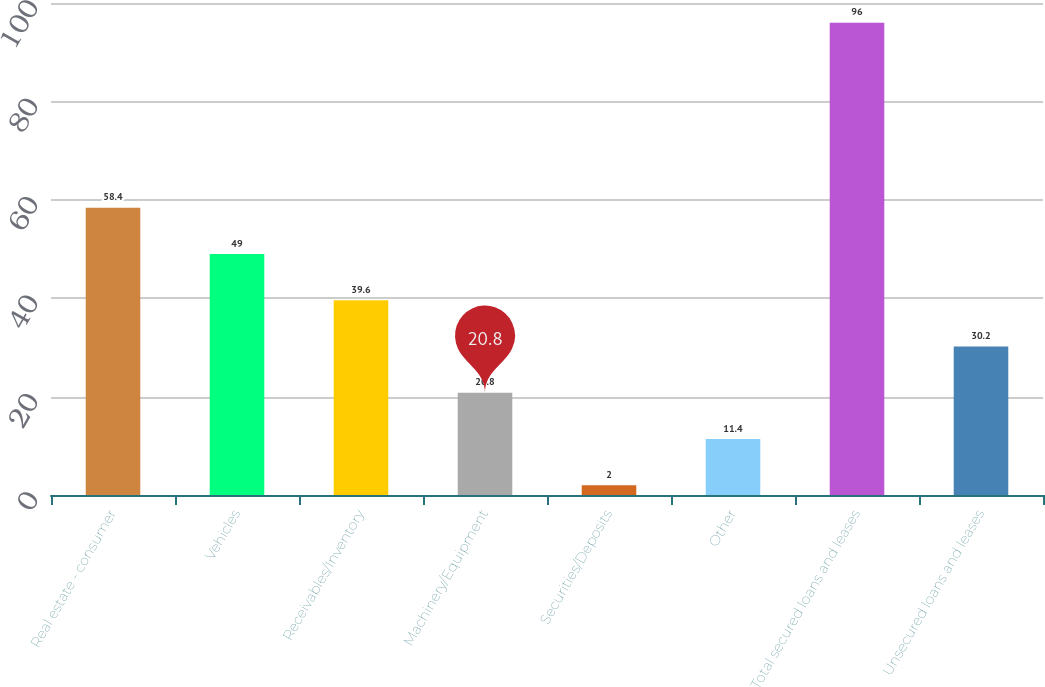<chart> <loc_0><loc_0><loc_500><loc_500><bar_chart><fcel>Real estate - consumer<fcel>Vehicles<fcel>Receivables/Inventory<fcel>Machinery/Equipment<fcel>Securities/Deposits<fcel>Other<fcel>Total secured loans and leases<fcel>Unsecured loans and leases<nl><fcel>58.4<fcel>49<fcel>39.6<fcel>20.8<fcel>2<fcel>11.4<fcel>96<fcel>30.2<nl></chart> 